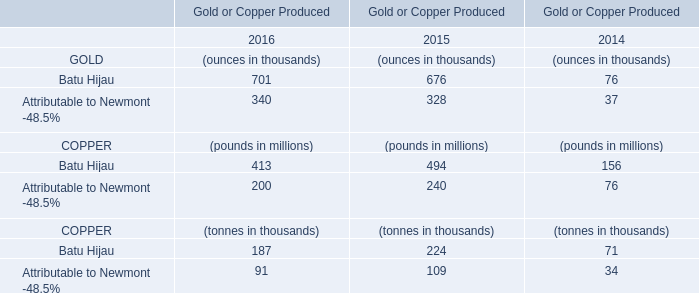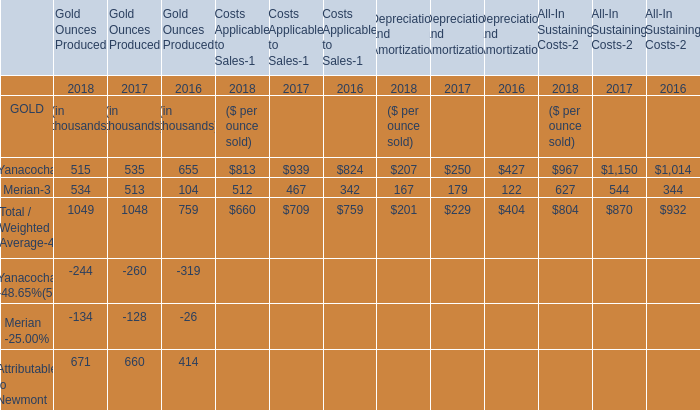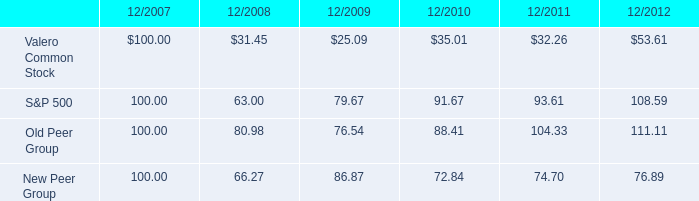what was the biggest decline , in percentage , from 2007-2008 , among the four groups? 
Computations: ((100 - 31.45) / 100)
Answer: 0.6855. 